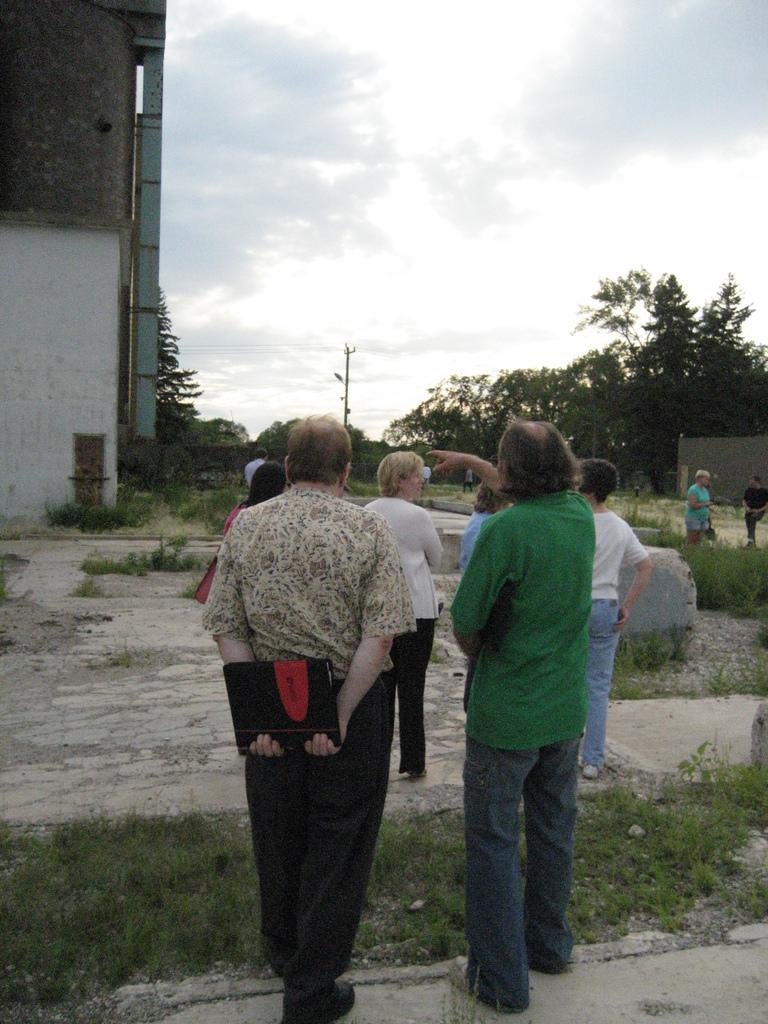What is happening in the image? There are persons standing in the image. What type of terrain is visible at the bottom of the image? There is grass at the bottom of the image. What can be seen in the background of the image? There is sand, trees, and buildings in the background of the image. What is visible at the top of the image? The sky is visible at the top of the image. What type of pancake is being served on the train in the image? There is no train or pancake present in the image. Can you see any icicles hanging from the trees in the image? There is no mention of icicles in the image, and the presence of trees does not necessarily imply the existence of icicles. 